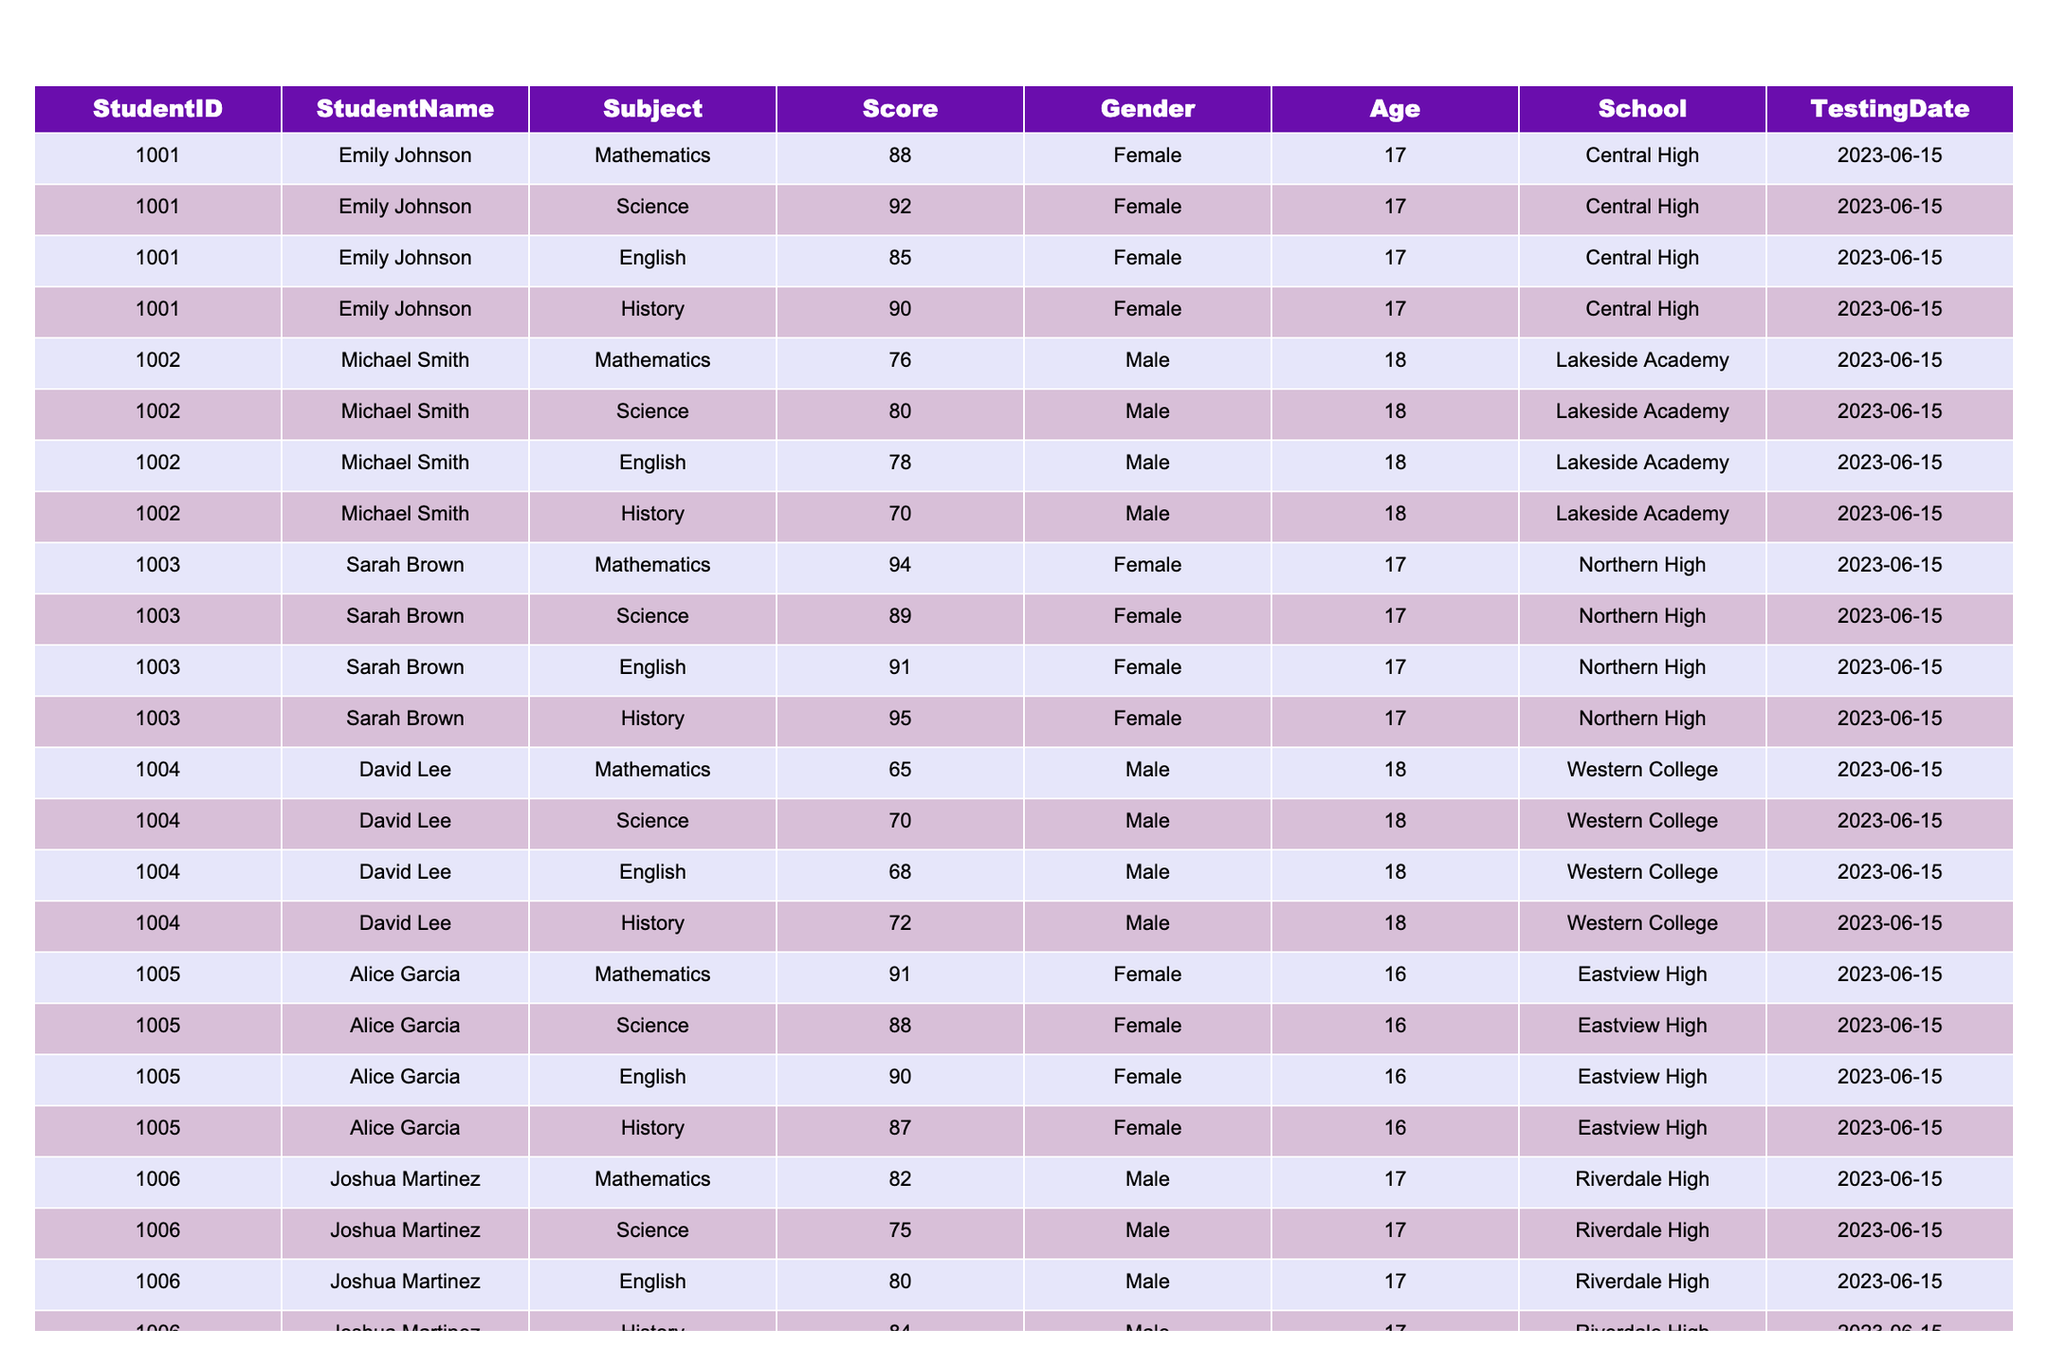What is the highest score in Mathematics? By scanning the Mathematics scores in the table, the highest score listed is 94, achieved by Sarah Brown.
Answer: 94 What is the average score in English for all students? To find the average, sum all English scores: (85 + 78 + 91 + 68 + 90 + 80 + 93) = 605. There are 7 students, so the average is 605/7 ≈ 86.43.
Answer: 86.43 Did any student score below 70 in History? Checking the History scores, David Lee scored 72, which is above 70, but Michael Smith scored 70, which is equal to 70. Thus, no student scored below 70.
Answer: No Who scored the highest in Science? By examining the Science scores, the highest score is 92, which was scored by Emily Johnson.
Answer: 92 What is the total score of Alice Garcia across all subjects? Alice Garcia's scores are 91 (Mathematics) + 88 (Science) + 90 (English) + 87 (History) = 356.
Answer: 356 Is there a female student who scored lower than 80 in Mathematics? Looking through the Mathematics scores, the lowest score for a female student is Emily Johnson's 88, so no female student scored lower than 80.
Answer: No What is the difference between the highest and lowest scores in History? The highest score in History is 95 (Olivia Wilson) and the lowest score is 70 (Michael Smith). The difference is 95 - 70 = 25.
Answer: 25 How many students scored above average in Science? The average score in Science is calculated as (92 + 80 + 89 + 70 + 88 + 75 + 90) / 7 = 82.57. Students scoring above this are Emily Johnson (92), Sarah Brown (89), and Olivia Wilson (90), totaling 3 students.
Answer: 3 